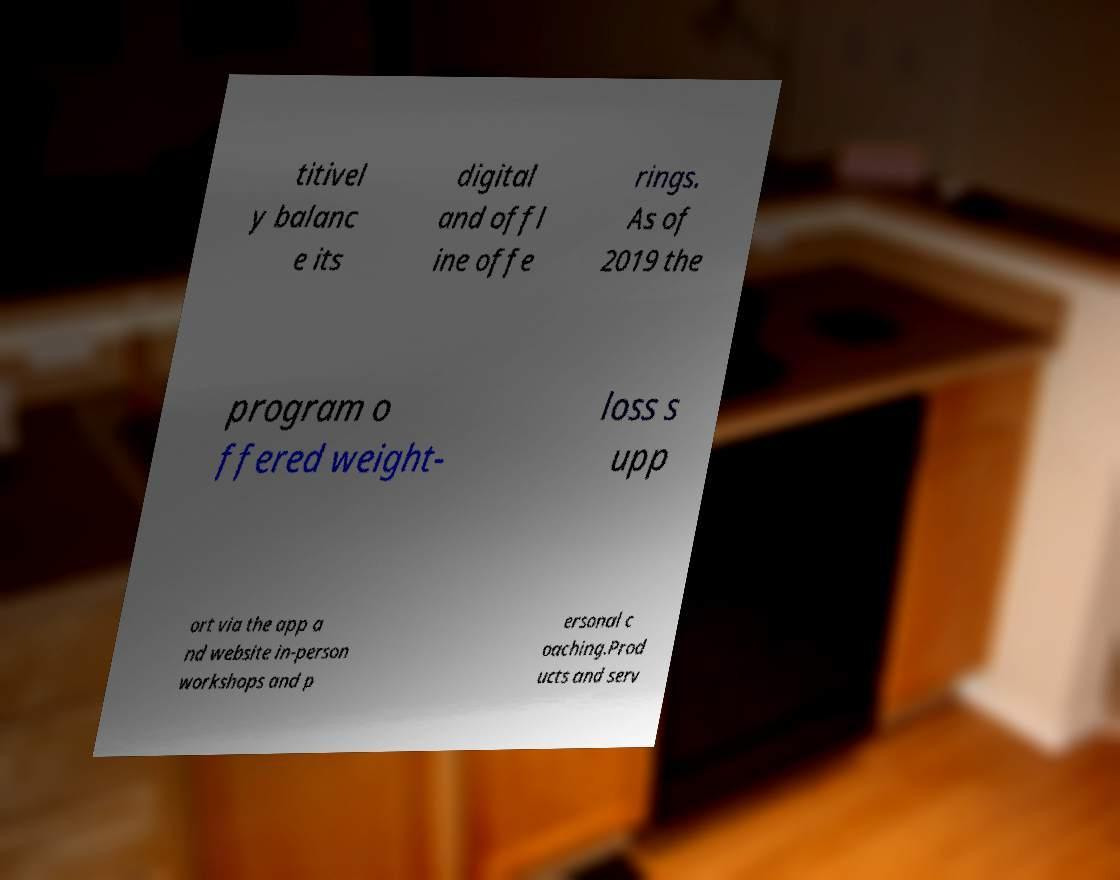Please read and relay the text visible in this image. What does it say? titivel y balanc e its digital and offl ine offe rings. As of 2019 the program o ffered weight- loss s upp ort via the app a nd website in-person workshops and p ersonal c oaching.Prod ucts and serv 